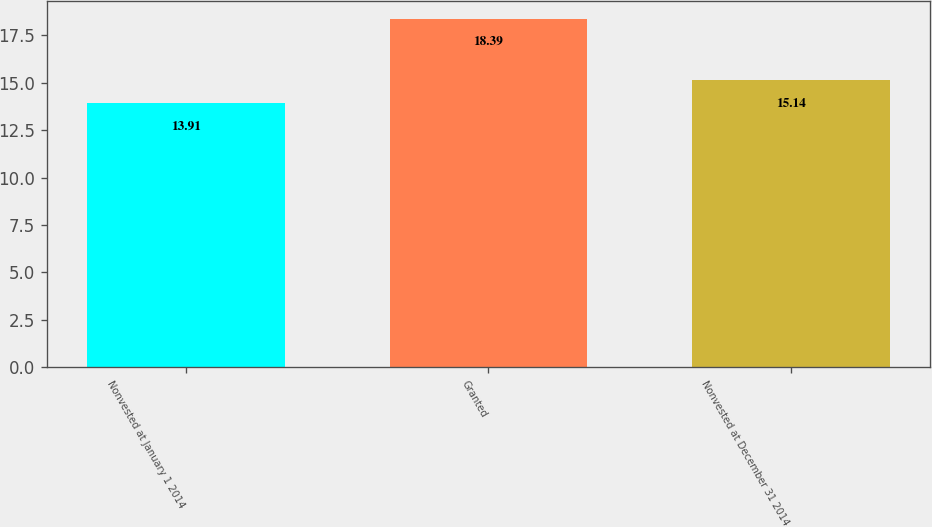<chart> <loc_0><loc_0><loc_500><loc_500><bar_chart><fcel>Nonvested at January 1 2014<fcel>Granted<fcel>Nonvested at December 31 2014<nl><fcel>13.91<fcel>18.39<fcel>15.14<nl></chart> 